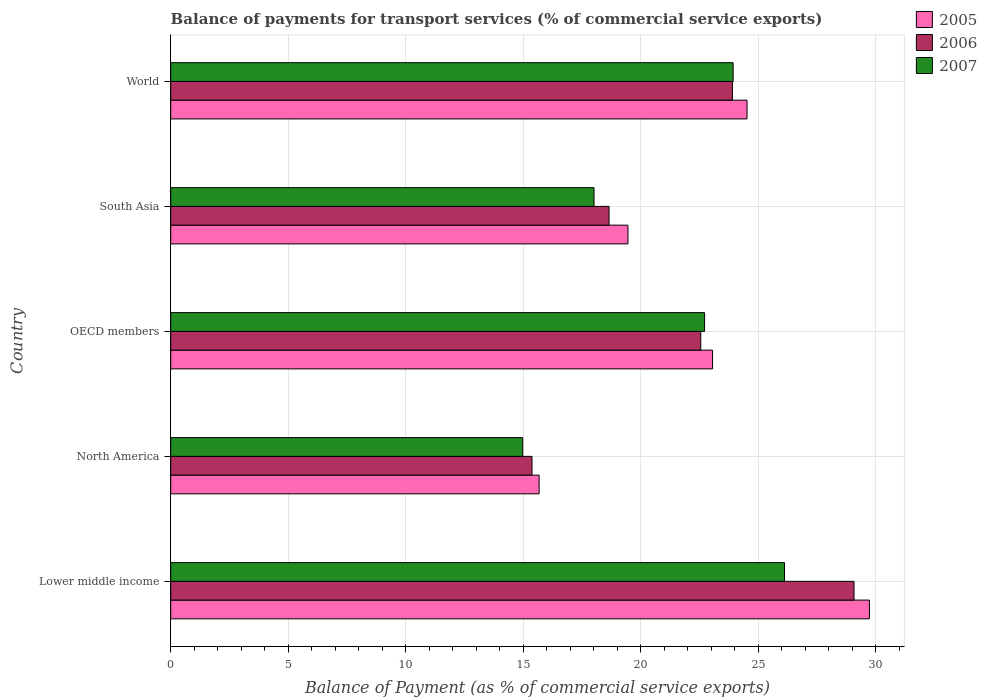How many different coloured bars are there?
Keep it short and to the point. 3. How many groups of bars are there?
Make the answer very short. 5. Are the number of bars on each tick of the Y-axis equal?
Keep it short and to the point. Yes. What is the balance of payments for transport services in 2005 in North America?
Ensure brevity in your answer.  15.67. Across all countries, what is the maximum balance of payments for transport services in 2005?
Your response must be concise. 29.72. Across all countries, what is the minimum balance of payments for transport services in 2005?
Your response must be concise. 15.67. In which country was the balance of payments for transport services in 2005 maximum?
Give a very brief answer. Lower middle income. In which country was the balance of payments for transport services in 2006 minimum?
Offer a very short reply. North America. What is the total balance of payments for transport services in 2006 in the graph?
Your answer should be very brief. 109.54. What is the difference between the balance of payments for transport services in 2006 in North America and that in South Asia?
Keep it short and to the point. -3.28. What is the difference between the balance of payments for transport services in 2005 in World and the balance of payments for transport services in 2006 in OECD members?
Your answer should be very brief. 1.97. What is the average balance of payments for transport services in 2007 per country?
Your answer should be compact. 21.15. What is the difference between the balance of payments for transport services in 2005 and balance of payments for transport services in 2007 in OECD members?
Ensure brevity in your answer.  0.34. In how many countries, is the balance of payments for transport services in 2005 greater than 30 %?
Give a very brief answer. 0. What is the ratio of the balance of payments for transport services in 2007 in North America to that in World?
Provide a short and direct response. 0.63. What is the difference between the highest and the second highest balance of payments for transport services in 2006?
Keep it short and to the point. 5.17. What is the difference between the highest and the lowest balance of payments for transport services in 2006?
Provide a succinct answer. 13.7. What does the 2nd bar from the top in World represents?
Your response must be concise. 2006. How many bars are there?
Your answer should be very brief. 15. Are all the bars in the graph horizontal?
Ensure brevity in your answer.  Yes. How many countries are there in the graph?
Provide a succinct answer. 5. What is the difference between two consecutive major ticks on the X-axis?
Your answer should be very brief. 5. How many legend labels are there?
Your response must be concise. 3. What is the title of the graph?
Offer a terse response. Balance of payments for transport services (% of commercial service exports). Does "1974" appear as one of the legend labels in the graph?
Provide a short and direct response. No. What is the label or title of the X-axis?
Offer a very short reply. Balance of Payment (as % of commercial service exports). What is the label or title of the Y-axis?
Provide a succinct answer. Country. What is the Balance of Payment (as % of commercial service exports) of 2005 in Lower middle income?
Give a very brief answer. 29.72. What is the Balance of Payment (as % of commercial service exports) of 2006 in Lower middle income?
Your answer should be compact. 29.07. What is the Balance of Payment (as % of commercial service exports) in 2007 in Lower middle income?
Your answer should be compact. 26.11. What is the Balance of Payment (as % of commercial service exports) of 2005 in North America?
Your response must be concise. 15.67. What is the Balance of Payment (as % of commercial service exports) of 2006 in North America?
Ensure brevity in your answer.  15.37. What is the Balance of Payment (as % of commercial service exports) in 2007 in North America?
Give a very brief answer. 14.97. What is the Balance of Payment (as % of commercial service exports) in 2005 in OECD members?
Your answer should be very brief. 23.05. What is the Balance of Payment (as % of commercial service exports) in 2006 in OECD members?
Ensure brevity in your answer.  22.55. What is the Balance of Payment (as % of commercial service exports) of 2007 in OECD members?
Make the answer very short. 22.71. What is the Balance of Payment (as % of commercial service exports) of 2005 in South Asia?
Make the answer very short. 19.45. What is the Balance of Payment (as % of commercial service exports) in 2006 in South Asia?
Give a very brief answer. 18.65. What is the Balance of Payment (as % of commercial service exports) in 2007 in South Asia?
Provide a short and direct response. 18.01. What is the Balance of Payment (as % of commercial service exports) in 2005 in World?
Keep it short and to the point. 24.52. What is the Balance of Payment (as % of commercial service exports) of 2006 in World?
Your answer should be very brief. 23.9. What is the Balance of Payment (as % of commercial service exports) in 2007 in World?
Offer a terse response. 23.93. Across all countries, what is the maximum Balance of Payment (as % of commercial service exports) of 2005?
Your answer should be compact. 29.72. Across all countries, what is the maximum Balance of Payment (as % of commercial service exports) in 2006?
Your answer should be very brief. 29.07. Across all countries, what is the maximum Balance of Payment (as % of commercial service exports) in 2007?
Ensure brevity in your answer.  26.11. Across all countries, what is the minimum Balance of Payment (as % of commercial service exports) in 2005?
Your answer should be very brief. 15.67. Across all countries, what is the minimum Balance of Payment (as % of commercial service exports) of 2006?
Your response must be concise. 15.37. Across all countries, what is the minimum Balance of Payment (as % of commercial service exports) in 2007?
Your answer should be very brief. 14.97. What is the total Balance of Payment (as % of commercial service exports) in 2005 in the graph?
Your answer should be very brief. 112.42. What is the total Balance of Payment (as % of commercial service exports) of 2006 in the graph?
Keep it short and to the point. 109.54. What is the total Balance of Payment (as % of commercial service exports) in 2007 in the graph?
Give a very brief answer. 105.73. What is the difference between the Balance of Payment (as % of commercial service exports) of 2005 in Lower middle income and that in North America?
Ensure brevity in your answer.  14.05. What is the difference between the Balance of Payment (as % of commercial service exports) in 2006 in Lower middle income and that in North America?
Your response must be concise. 13.7. What is the difference between the Balance of Payment (as % of commercial service exports) in 2007 in Lower middle income and that in North America?
Give a very brief answer. 11.14. What is the difference between the Balance of Payment (as % of commercial service exports) of 2005 in Lower middle income and that in OECD members?
Give a very brief answer. 6.67. What is the difference between the Balance of Payment (as % of commercial service exports) of 2006 in Lower middle income and that in OECD members?
Offer a very short reply. 6.52. What is the difference between the Balance of Payment (as % of commercial service exports) in 2007 in Lower middle income and that in OECD members?
Give a very brief answer. 3.4. What is the difference between the Balance of Payment (as % of commercial service exports) of 2005 in Lower middle income and that in South Asia?
Give a very brief answer. 10.27. What is the difference between the Balance of Payment (as % of commercial service exports) of 2006 in Lower middle income and that in South Asia?
Offer a very short reply. 10.42. What is the difference between the Balance of Payment (as % of commercial service exports) in 2007 in Lower middle income and that in South Asia?
Your answer should be compact. 8.1. What is the difference between the Balance of Payment (as % of commercial service exports) in 2005 in Lower middle income and that in World?
Your answer should be compact. 5.21. What is the difference between the Balance of Payment (as % of commercial service exports) in 2006 in Lower middle income and that in World?
Offer a terse response. 5.17. What is the difference between the Balance of Payment (as % of commercial service exports) of 2007 in Lower middle income and that in World?
Offer a terse response. 2.19. What is the difference between the Balance of Payment (as % of commercial service exports) in 2005 in North America and that in OECD members?
Offer a terse response. -7.38. What is the difference between the Balance of Payment (as % of commercial service exports) of 2006 in North America and that in OECD members?
Give a very brief answer. -7.18. What is the difference between the Balance of Payment (as % of commercial service exports) of 2007 in North America and that in OECD members?
Offer a terse response. -7.74. What is the difference between the Balance of Payment (as % of commercial service exports) of 2005 in North America and that in South Asia?
Your answer should be very brief. -3.78. What is the difference between the Balance of Payment (as % of commercial service exports) in 2006 in North America and that in South Asia?
Provide a short and direct response. -3.28. What is the difference between the Balance of Payment (as % of commercial service exports) in 2007 in North America and that in South Asia?
Ensure brevity in your answer.  -3.03. What is the difference between the Balance of Payment (as % of commercial service exports) of 2005 in North America and that in World?
Your answer should be compact. -8.84. What is the difference between the Balance of Payment (as % of commercial service exports) of 2006 in North America and that in World?
Offer a very short reply. -8.53. What is the difference between the Balance of Payment (as % of commercial service exports) in 2007 in North America and that in World?
Keep it short and to the point. -8.95. What is the difference between the Balance of Payment (as % of commercial service exports) of 2006 in OECD members and that in South Asia?
Your answer should be very brief. 3.9. What is the difference between the Balance of Payment (as % of commercial service exports) of 2007 in OECD members and that in South Asia?
Keep it short and to the point. 4.7. What is the difference between the Balance of Payment (as % of commercial service exports) in 2005 in OECD members and that in World?
Offer a terse response. -1.47. What is the difference between the Balance of Payment (as % of commercial service exports) in 2006 in OECD members and that in World?
Make the answer very short. -1.35. What is the difference between the Balance of Payment (as % of commercial service exports) of 2007 in OECD members and that in World?
Provide a succinct answer. -1.21. What is the difference between the Balance of Payment (as % of commercial service exports) in 2005 in South Asia and that in World?
Your response must be concise. -5.07. What is the difference between the Balance of Payment (as % of commercial service exports) in 2006 in South Asia and that in World?
Make the answer very short. -5.25. What is the difference between the Balance of Payment (as % of commercial service exports) in 2007 in South Asia and that in World?
Your response must be concise. -5.92. What is the difference between the Balance of Payment (as % of commercial service exports) in 2005 in Lower middle income and the Balance of Payment (as % of commercial service exports) in 2006 in North America?
Make the answer very short. 14.35. What is the difference between the Balance of Payment (as % of commercial service exports) in 2005 in Lower middle income and the Balance of Payment (as % of commercial service exports) in 2007 in North America?
Your answer should be compact. 14.75. What is the difference between the Balance of Payment (as % of commercial service exports) in 2006 in Lower middle income and the Balance of Payment (as % of commercial service exports) in 2007 in North America?
Make the answer very short. 14.09. What is the difference between the Balance of Payment (as % of commercial service exports) of 2005 in Lower middle income and the Balance of Payment (as % of commercial service exports) of 2006 in OECD members?
Give a very brief answer. 7.17. What is the difference between the Balance of Payment (as % of commercial service exports) in 2005 in Lower middle income and the Balance of Payment (as % of commercial service exports) in 2007 in OECD members?
Keep it short and to the point. 7.01. What is the difference between the Balance of Payment (as % of commercial service exports) of 2006 in Lower middle income and the Balance of Payment (as % of commercial service exports) of 2007 in OECD members?
Your answer should be very brief. 6.36. What is the difference between the Balance of Payment (as % of commercial service exports) in 2005 in Lower middle income and the Balance of Payment (as % of commercial service exports) in 2006 in South Asia?
Ensure brevity in your answer.  11.08. What is the difference between the Balance of Payment (as % of commercial service exports) of 2005 in Lower middle income and the Balance of Payment (as % of commercial service exports) of 2007 in South Asia?
Keep it short and to the point. 11.72. What is the difference between the Balance of Payment (as % of commercial service exports) in 2006 in Lower middle income and the Balance of Payment (as % of commercial service exports) in 2007 in South Asia?
Provide a succinct answer. 11.06. What is the difference between the Balance of Payment (as % of commercial service exports) of 2005 in Lower middle income and the Balance of Payment (as % of commercial service exports) of 2006 in World?
Keep it short and to the point. 5.83. What is the difference between the Balance of Payment (as % of commercial service exports) of 2005 in Lower middle income and the Balance of Payment (as % of commercial service exports) of 2007 in World?
Your answer should be very brief. 5.8. What is the difference between the Balance of Payment (as % of commercial service exports) in 2006 in Lower middle income and the Balance of Payment (as % of commercial service exports) in 2007 in World?
Keep it short and to the point. 5.14. What is the difference between the Balance of Payment (as % of commercial service exports) of 2005 in North America and the Balance of Payment (as % of commercial service exports) of 2006 in OECD members?
Your answer should be very brief. -6.88. What is the difference between the Balance of Payment (as % of commercial service exports) in 2005 in North America and the Balance of Payment (as % of commercial service exports) in 2007 in OECD members?
Keep it short and to the point. -7.04. What is the difference between the Balance of Payment (as % of commercial service exports) in 2006 in North America and the Balance of Payment (as % of commercial service exports) in 2007 in OECD members?
Offer a terse response. -7.34. What is the difference between the Balance of Payment (as % of commercial service exports) of 2005 in North America and the Balance of Payment (as % of commercial service exports) of 2006 in South Asia?
Ensure brevity in your answer.  -2.98. What is the difference between the Balance of Payment (as % of commercial service exports) of 2005 in North America and the Balance of Payment (as % of commercial service exports) of 2007 in South Asia?
Offer a very short reply. -2.34. What is the difference between the Balance of Payment (as % of commercial service exports) of 2006 in North America and the Balance of Payment (as % of commercial service exports) of 2007 in South Asia?
Your response must be concise. -2.64. What is the difference between the Balance of Payment (as % of commercial service exports) of 2005 in North America and the Balance of Payment (as % of commercial service exports) of 2006 in World?
Give a very brief answer. -8.22. What is the difference between the Balance of Payment (as % of commercial service exports) of 2005 in North America and the Balance of Payment (as % of commercial service exports) of 2007 in World?
Ensure brevity in your answer.  -8.25. What is the difference between the Balance of Payment (as % of commercial service exports) in 2006 in North America and the Balance of Payment (as % of commercial service exports) in 2007 in World?
Make the answer very short. -8.56. What is the difference between the Balance of Payment (as % of commercial service exports) in 2005 in OECD members and the Balance of Payment (as % of commercial service exports) in 2006 in South Asia?
Your answer should be very brief. 4.4. What is the difference between the Balance of Payment (as % of commercial service exports) in 2005 in OECD members and the Balance of Payment (as % of commercial service exports) in 2007 in South Asia?
Keep it short and to the point. 5.04. What is the difference between the Balance of Payment (as % of commercial service exports) of 2006 in OECD members and the Balance of Payment (as % of commercial service exports) of 2007 in South Asia?
Keep it short and to the point. 4.54. What is the difference between the Balance of Payment (as % of commercial service exports) of 2005 in OECD members and the Balance of Payment (as % of commercial service exports) of 2006 in World?
Ensure brevity in your answer.  -0.85. What is the difference between the Balance of Payment (as % of commercial service exports) in 2005 in OECD members and the Balance of Payment (as % of commercial service exports) in 2007 in World?
Your response must be concise. -0.87. What is the difference between the Balance of Payment (as % of commercial service exports) in 2006 in OECD members and the Balance of Payment (as % of commercial service exports) in 2007 in World?
Make the answer very short. -1.38. What is the difference between the Balance of Payment (as % of commercial service exports) of 2005 in South Asia and the Balance of Payment (as % of commercial service exports) of 2006 in World?
Your response must be concise. -4.45. What is the difference between the Balance of Payment (as % of commercial service exports) in 2005 in South Asia and the Balance of Payment (as % of commercial service exports) in 2007 in World?
Provide a short and direct response. -4.47. What is the difference between the Balance of Payment (as % of commercial service exports) in 2006 in South Asia and the Balance of Payment (as % of commercial service exports) in 2007 in World?
Give a very brief answer. -5.28. What is the average Balance of Payment (as % of commercial service exports) of 2005 per country?
Keep it short and to the point. 22.48. What is the average Balance of Payment (as % of commercial service exports) in 2006 per country?
Offer a terse response. 21.91. What is the average Balance of Payment (as % of commercial service exports) of 2007 per country?
Give a very brief answer. 21.15. What is the difference between the Balance of Payment (as % of commercial service exports) in 2005 and Balance of Payment (as % of commercial service exports) in 2006 in Lower middle income?
Offer a very short reply. 0.66. What is the difference between the Balance of Payment (as % of commercial service exports) of 2005 and Balance of Payment (as % of commercial service exports) of 2007 in Lower middle income?
Offer a very short reply. 3.61. What is the difference between the Balance of Payment (as % of commercial service exports) in 2006 and Balance of Payment (as % of commercial service exports) in 2007 in Lower middle income?
Provide a succinct answer. 2.96. What is the difference between the Balance of Payment (as % of commercial service exports) of 2005 and Balance of Payment (as % of commercial service exports) of 2006 in North America?
Offer a very short reply. 0.3. What is the difference between the Balance of Payment (as % of commercial service exports) in 2005 and Balance of Payment (as % of commercial service exports) in 2007 in North America?
Keep it short and to the point. 0.7. What is the difference between the Balance of Payment (as % of commercial service exports) in 2006 and Balance of Payment (as % of commercial service exports) in 2007 in North America?
Offer a very short reply. 0.4. What is the difference between the Balance of Payment (as % of commercial service exports) of 2005 and Balance of Payment (as % of commercial service exports) of 2006 in OECD members?
Your response must be concise. 0.5. What is the difference between the Balance of Payment (as % of commercial service exports) in 2005 and Balance of Payment (as % of commercial service exports) in 2007 in OECD members?
Make the answer very short. 0.34. What is the difference between the Balance of Payment (as % of commercial service exports) of 2006 and Balance of Payment (as % of commercial service exports) of 2007 in OECD members?
Your response must be concise. -0.16. What is the difference between the Balance of Payment (as % of commercial service exports) of 2005 and Balance of Payment (as % of commercial service exports) of 2006 in South Asia?
Your answer should be compact. 0.8. What is the difference between the Balance of Payment (as % of commercial service exports) of 2005 and Balance of Payment (as % of commercial service exports) of 2007 in South Asia?
Offer a terse response. 1.44. What is the difference between the Balance of Payment (as % of commercial service exports) of 2006 and Balance of Payment (as % of commercial service exports) of 2007 in South Asia?
Give a very brief answer. 0.64. What is the difference between the Balance of Payment (as % of commercial service exports) of 2005 and Balance of Payment (as % of commercial service exports) of 2006 in World?
Your answer should be compact. 0.62. What is the difference between the Balance of Payment (as % of commercial service exports) of 2005 and Balance of Payment (as % of commercial service exports) of 2007 in World?
Provide a succinct answer. 0.59. What is the difference between the Balance of Payment (as % of commercial service exports) of 2006 and Balance of Payment (as % of commercial service exports) of 2007 in World?
Offer a very short reply. -0.03. What is the ratio of the Balance of Payment (as % of commercial service exports) in 2005 in Lower middle income to that in North America?
Keep it short and to the point. 1.9. What is the ratio of the Balance of Payment (as % of commercial service exports) of 2006 in Lower middle income to that in North America?
Offer a very short reply. 1.89. What is the ratio of the Balance of Payment (as % of commercial service exports) of 2007 in Lower middle income to that in North America?
Offer a very short reply. 1.74. What is the ratio of the Balance of Payment (as % of commercial service exports) of 2005 in Lower middle income to that in OECD members?
Provide a succinct answer. 1.29. What is the ratio of the Balance of Payment (as % of commercial service exports) of 2006 in Lower middle income to that in OECD members?
Offer a terse response. 1.29. What is the ratio of the Balance of Payment (as % of commercial service exports) of 2007 in Lower middle income to that in OECD members?
Make the answer very short. 1.15. What is the ratio of the Balance of Payment (as % of commercial service exports) in 2005 in Lower middle income to that in South Asia?
Make the answer very short. 1.53. What is the ratio of the Balance of Payment (as % of commercial service exports) in 2006 in Lower middle income to that in South Asia?
Keep it short and to the point. 1.56. What is the ratio of the Balance of Payment (as % of commercial service exports) in 2007 in Lower middle income to that in South Asia?
Provide a succinct answer. 1.45. What is the ratio of the Balance of Payment (as % of commercial service exports) of 2005 in Lower middle income to that in World?
Keep it short and to the point. 1.21. What is the ratio of the Balance of Payment (as % of commercial service exports) in 2006 in Lower middle income to that in World?
Provide a succinct answer. 1.22. What is the ratio of the Balance of Payment (as % of commercial service exports) in 2007 in Lower middle income to that in World?
Give a very brief answer. 1.09. What is the ratio of the Balance of Payment (as % of commercial service exports) in 2005 in North America to that in OECD members?
Your answer should be compact. 0.68. What is the ratio of the Balance of Payment (as % of commercial service exports) of 2006 in North America to that in OECD members?
Your answer should be compact. 0.68. What is the ratio of the Balance of Payment (as % of commercial service exports) in 2007 in North America to that in OECD members?
Offer a terse response. 0.66. What is the ratio of the Balance of Payment (as % of commercial service exports) in 2005 in North America to that in South Asia?
Make the answer very short. 0.81. What is the ratio of the Balance of Payment (as % of commercial service exports) of 2006 in North America to that in South Asia?
Provide a short and direct response. 0.82. What is the ratio of the Balance of Payment (as % of commercial service exports) in 2007 in North America to that in South Asia?
Keep it short and to the point. 0.83. What is the ratio of the Balance of Payment (as % of commercial service exports) of 2005 in North America to that in World?
Ensure brevity in your answer.  0.64. What is the ratio of the Balance of Payment (as % of commercial service exports) in 2006 in North America to that in World?
Keep it short and to the point. 0.64. What is the ratio of the Balance of Payment (as % of commercial service exports) in 2007 in North America to that in World?
Offer a terse response. 0.63. What is the ratio of the Balance of Payment (as % of commercial service exports) in 2005 in OECD members to that in South Asia?
Offer a very short reply. 1.19. What is the ratio of the Balance of Payment (as % of commercial service exports) in 2006 in OECD members to that in South Asia?
Provide a short and direct response. 1.21. What is the ratio of the Balance of Payment (as % of commercial service exports) of 2007 in OECD members to that in South Asia?
Your response must be concise. 1.26. What is the ratio of the Balance of Payment (as % of commercial service exports) of 2005 in OECD members to that in World?
Your response must be concise. 0.94. What is the ratio of the Balance of Payment (as % of commercial service exports) in 2006 in OECD members to that in World?
Keep it short and to the point. 0.94. What is the ratio of the Balance of Payment (as % of commercial service exports) in 2007 in OECD members to that in World?
Provide a succinct answer. 0.95. What is the ratio of the Balance of Payment (as % of commercial service exports) of 2005 in South Asia to that in World?
Give a very brief answer. 0.79. What is the ratio of the Balance of Payment (as % of commercial service exports) in 2006 in South Asia to that in World?
Your answer should be compact. 0.78. What is the ratio of the Balance of Payment (as % of commercial service exports) of 2007 in South Asia to that in World?
Provide a short and direct response. 0.75. What is the difference between the highest and the second highest Balance of Payment (as % of commercial service exports) of 2005?
Give a very brief answer. 5.21. What is the difference between the highest and the second highest Balance of Payment (as % of commercial service exports) in 2006?
Your response must be concise. 5.17. What is the difference between the highest and the second highest Balance of Payment (as % of commercial service exports) of 2007?
Give a very brief answer. 2.19. What is the difference between the highest and the lowest Balance of Payment (as % of commercial service exports) of 2005?
Offer a very short reply. 14.05. What is the difference between the highest and the lowest Balance of Payment (as % of commercial service exports) of 2006?
Provide a short and direct response. 13.7. What is the difference between the highest and the lowest Balance of Payment (as % of commercial service exports) of 2007?
Make the answer very short. 11.14. 